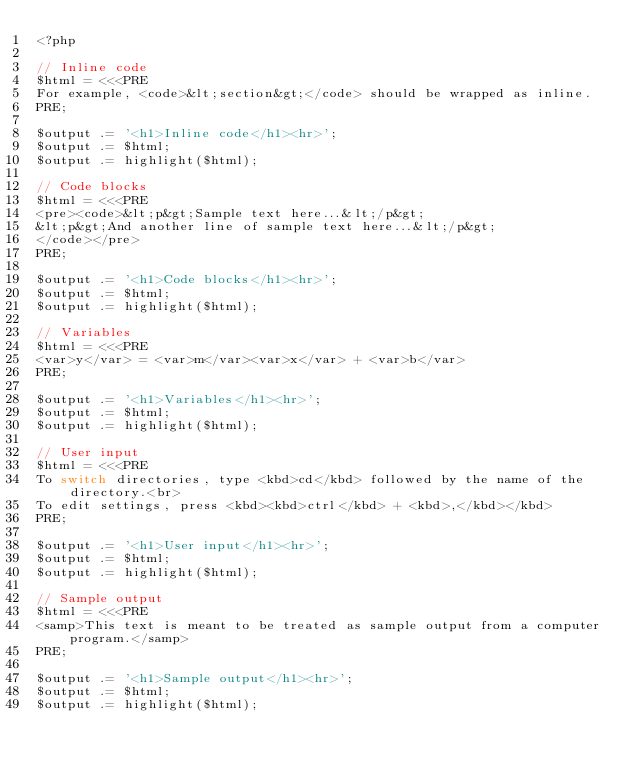<code> <loc_0><loc_0><loc_500><loc_500><_PHP_><?php

// Inline code
$html = <<<PRE
For example, <code>&lt;section&gt;</code> should be wrapped as inline.
PRE;

$output .= '<h1>Inline code</h1><hr>';
$output .= $html;
$output .= highlight($html);

// Code blocks
$html = <<<PRE
<pre><code>&lt;p&gt;Sample text here...&lt;/p&gt;
&lt;p&gt;And another line of sample text here...&lt;/p&gt;
</code></pre>
PRE;

$output .= '<h1>Code blocks</h1><hr>';
$output .= $html;
$output .= highlight($html);

// Variables
$html = <<<PRE
<var>y</var> = <var>m</var><var>x</var> + <var>b</var>
PRE;

$output .= '<h1>Variables</h1><hr>';
$output .= $html;
$output .= highlight($html);

// User input
$html = <<<PRE
To switch directories, type <kbd>cd</kbd> followed by the name of the directory.<br>
To edit settings, press <kbd><kbd>ctrl</kbd> + <kbd>,</kbd></kbd>
PRE;

$output .= '<h1>User input</h1><hr>';
$output .= $html;
$output .= highlight($html);

// Sample output
$html = <<<PRE
<samp>This text is meant to be treated as sample output from a computer program.</samp>
PRE;

$output .= '<h1>Sample output</h1><hr>';
$output .= $html;
$output .= highlight($html);

</code> 